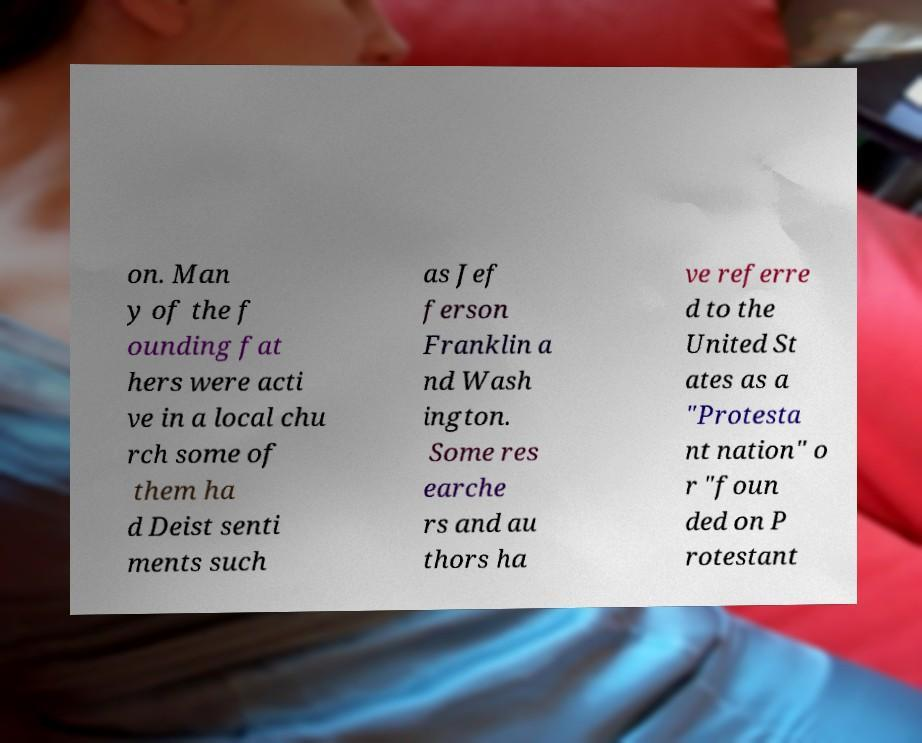There's text embedded in this image that I need extracted. Can you transcribe it verbatim? on. Man y of the f ounding fat hers were acti ve in a local chu rch some of them ha d Deist senti ments such as Jef ferson Franklin a nd Wash ington. Some res earche rs and au thors ha ve referre d to the United St ates as a "Protesta nt nation" o r "foun ded on P rotestant 